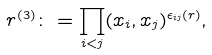Convert formula to latex. <formula><loc_0><loc_0><loc_500><loc_500>r ^ { ( 3 ) } \colon = \prod _ { i < j } ( x _ { i } , x _ { j } ) ^ { \epsilon _ { i j } ( r ) } ,</formula> 